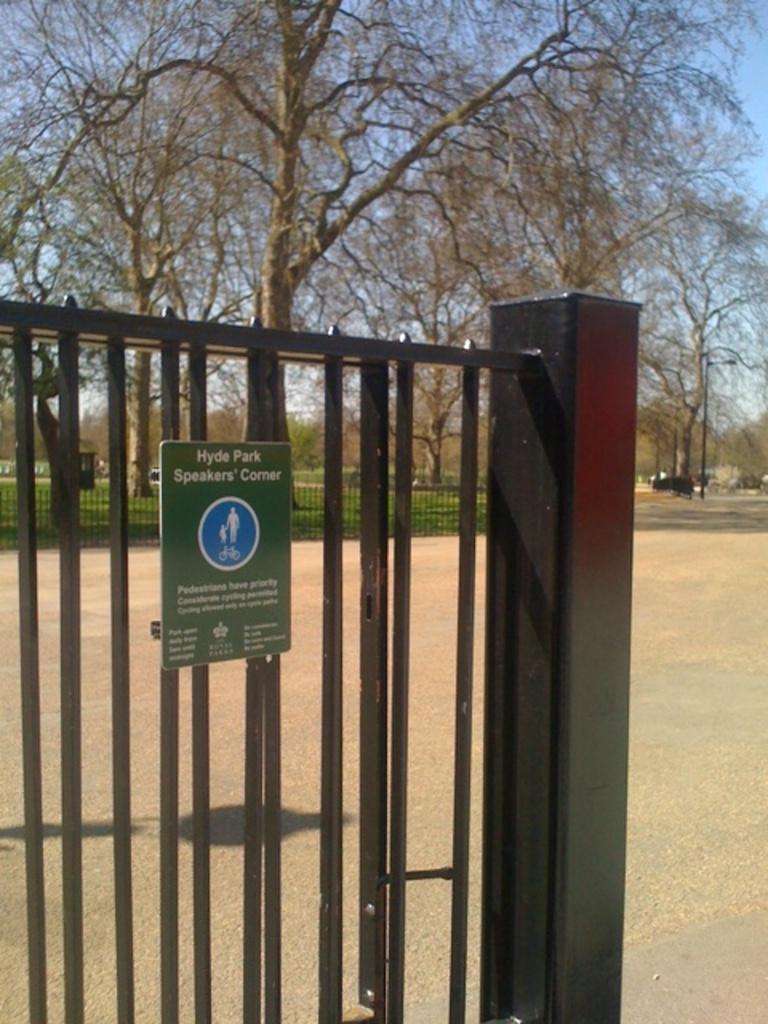Please provide a concise description of this image. In this image in front there is a gate. In the center of the image there is a road. There is a fence. In the background of the image there is grass on the surface. There are trees and sky. 